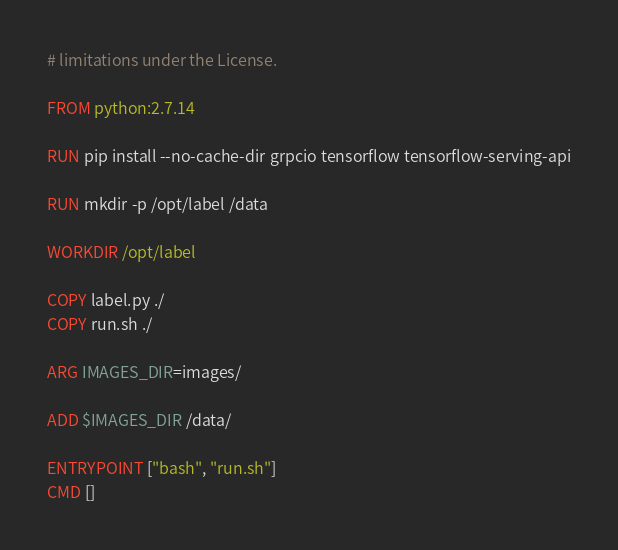Convert code to text. <code><loc_0><loc_0><loc_500><loc_500><_Dockerfile_># limitations under the License.

FROM python:2.7.14

RUN pip install --no-cache-dir grpcio tensorflow tensorflow-serving-api

RUN mkdir -p /opt/label /data

WORKDIR /opt/label

COPY label.py ./
COPY run.sh ./

ARG IMAGES_DIR=images/

ADD $IMAGES_DIR /data/

ENTRYPOINT ["bash", "run.sh"]
CMD []
</code> 